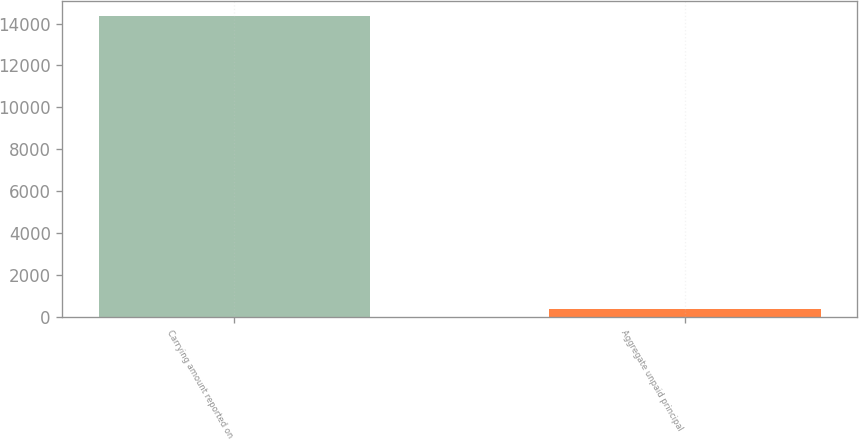Convert chart. <chart><loc_0><loc_0><loc_500><loc_500><bar_chart><fcel>Carrying amount reported on<fcel>Aggregate unpaid principal<nl><fcel>14338<fcel>390<nl></chart> 